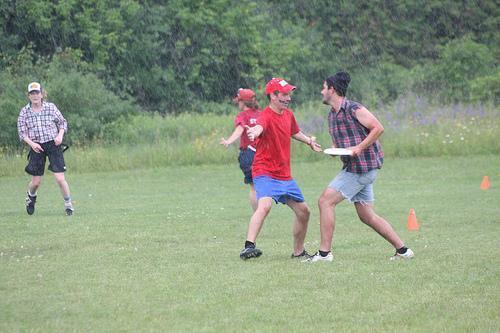How many people are in this picture?
Give a very brief answer. 4. 